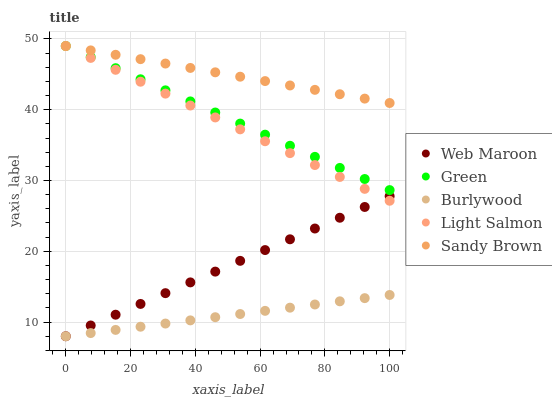Does Burlywood have the minimum area under the curve?
Answer yes or no. Yes. Does Sandy Brown have the maximum area under the curve?
Answer yes or no. Yes. Does Green have the minimum area under the curve?
Answer yes or no. No. Does Green have the maximum area under the curve?
Answer yes or no. No. Is Burlywood the smoothest?
Answer yes or no. Yes. Is Sandy Brown the roughest?
Answer yes or no. Yes. Is Green the smoothest?
Answer yes or no. No. Is Green the roughest?
Answer yes or no. No. Does Burlywood have the lowest value?
Answer yes or no. Yes. Does Green have the lowest value?
Answer yes or no. No. Does Sandy Brown have the highest value?
Answer yes or no. Yes. Does Web Maroon have the highest value?
Answer yes or no. No. Is Burlywood less than Light Salmon?
Answer yes or no. Yes. Is Sandy Brown greater than Web Maroon?
Answer yes or no. Yes. Does Burlywood intersect Web Maroon?
Answer yes or no. Yes. Is Burlywood less than Web Maroon?
Answer yes or no. No. Is Burlywood greater than Web Maroon?
Answer yes or no. No. Does Burlywood intersect Light Salmon?
Answer yes or no. No. 